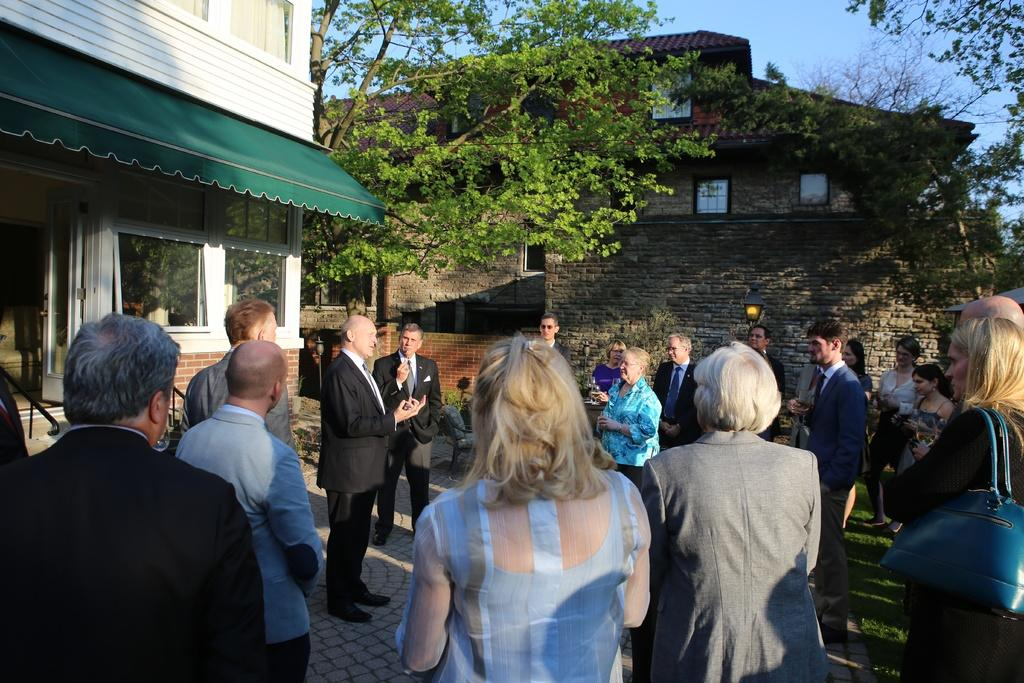What type of structure is visible in the image? There is a house in the image. What can be seen in the middle of the image? There are trees in the middle of the image. What is the other prominent feature in the image? There is a wall in the image. What are the people in the image doing? A group of persons is standing on the floor in front of the wall. What is visible at the top of the image? The sky is visible at the top of the image. What type of insurance policy is being discussed by the group of persons in the image? There is no indication in the image that a discussion about insurance is taking place. The group of persons is simply standing in front of the wall. 